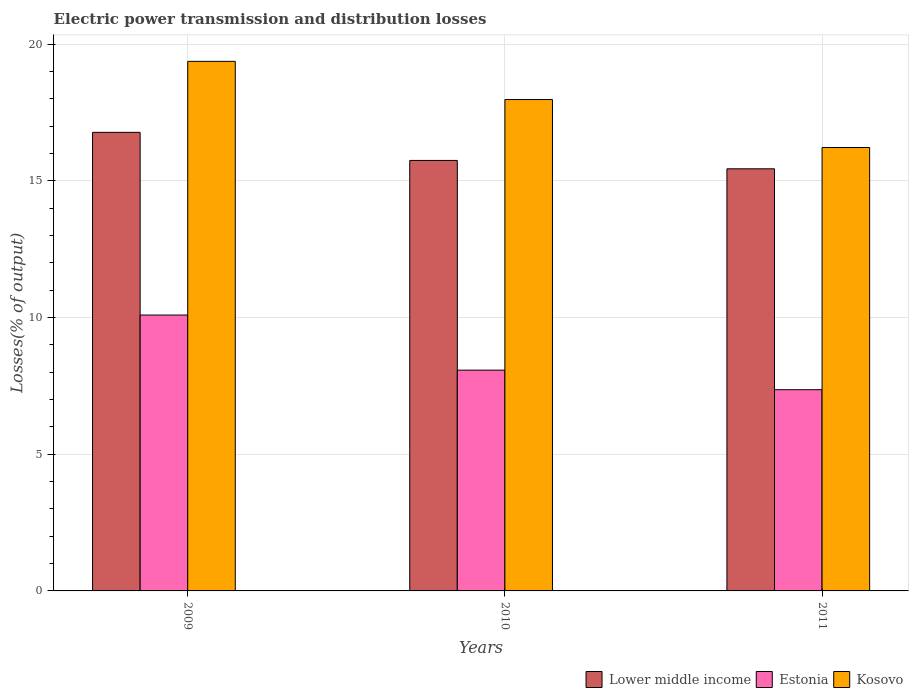How many different coloured bars are there?
Provide a succinct answer. 3. How many groups of bars are there?
Provide a succinct answer. 3. Are the number of bars on each tick of the X-axis equal?
Keep it short and to the point. Yes. What is the label of the 3rd group of bars from the left?
Offer a terse response. 2011. What is the electric power transmission and distribution losses in Lower middle income in 2011?
Offer a very short reply. 15.44. Across all years, what is the maximum electric power transmission and distribution losses in Estonia?
Offer a very short reply. 10.09. Across all years, what is the minimum electric power transmission and distribution losses in Kosovo?
Provide a succinct answer. 16.22. In which year was the electric power transmission and distribution losses in Lower middle income maximum?
Ensure brevity in your answer.  2009. In which year was the electric power transmission and distribution losses in Kosovo minimum?
Ensure brevity in your answer.  2011. What is the total electric power transmission and distribution losses in Estonia in the graph?
Provide a short and direct response. 25.53. What is the difference between the electric power transmission and distribution losses in Estonia in 2009 and that in 2010?
Your answer should be very brief. 2.02. What is the difference between the electric power transmission and distribution losses in Lower middle income in 2011 and the electric power transmission and distribution losses in Estonia in 2009?
Offer a terse response. 5.35. What is the average electric power transmission and distribution losses in Kosovo per year?
Offer a very short reply. 17.86. In the year 2011, what is the difference between the electric power transmission and distribution losses in Lower middle income and electric power transmission and distribution losses in Kosovo?
Ensure brevity in your answer.  -0.78. In how many years, is the electric power transmission and distribution losses in Kosovo greater than 18 %?
Your response must be concise. 1. What is the ratio of the electric power transmission and distribution losses in Kosovo in 2010 to that in 2011?
Give a very brief answer. 1.11. Is the electric power transmission and distribution losses in Lower middle income in 2009 less than that in 2010?
Provide a short and direct response. No. Is the difference between the electric power transmission and distribution losses in Lower middle income in 2009 and 2011 greater than the difference between the electric power transmission and distribution losses in Kosovo in 2009 and 2011?
Offer a very short reply. No. What is the difference between the highest and the second highest electric power transmission and distribution losses in Kosovo?
Your response must be concise. 1.4. What is the difference between the highest and the lowest electric power transmission and distribution losses in Estonia?
Provide a succinct answer. 2.73. In how many years, is the electric power transmission and distribution losses in Lower middle income greater than the average electric power transmission and distribution losses in Lower middle income taken over all years?
Your response must be concise. 1. Is the sum of the electric power transmission and distribution losses in Estonia in 2009 and 2011 greater than the maximum electric power transmission and distribution losses in Kosovo across all years?
Your response must be concise. No. What does the 3rd bar from the left in 2009 represents?
Keep it short and to the point. Kosovo. What does the 1st bar from the right in 2009 represents?
Provide a short and direct response. Kosovo. Is it the case that in every year, the sum of the electric power transmission and distribution losses in Lower middle income and electric power transmission and distribution losses in Estonia is greater than the electric power transmission and distribution losses in Kosovo?
Provide a short and direct response. Yes. Are all the bars in the graph horizontal?
Your response must be concise. No. What is the difference between two consecutive major ticks on the Y-axis?
Keep it short and to the point. 5. Are the values on the major ticks of Y-axis written in scientific E-notation?
Offer a terse response. No. Does the graph contain any zero values?
Offer a very short reply. No. Where does the legend appear in the graph?
Make the answer very short. Bottom right. What is the title of the graph?
Your response must be concise. Electric power transmission and distribution losses. Does "Benin" appear as one of the legend labels in the graph?
Your answer should be compact. No. What is the label or title of the X-axis?
Make the answer very short. Years. What is the label or title of the Y-axis?
Provide a succinct answer. Losses(% of output). What is the Losses(% of output) of Lower middle income in 2009?
Ensure brevity in your answer.  16.78. What is the Losses(% of output) of Estonia in 2009?
Provide a short and direct response. 10.09. What is the Losses(% of output) of Kosovo in 2009?
Provide a succinct answer. 19.37. What is the Losses(% of output) in Lower middle income in 2010?
Offer a very short reply. 15.75. What is the Losses(% of output) of Estonia in 2010?
Ensure brevity in your answer.  8.08. What is the Losses(% of output) in Kosovo in 2010?
Provide a short and direct response. 17.98. What is the Losses(% of output) in Lower middle income in 2011?
Provide a short and direct response. 15.44. What is the Losses(% of output) in Estonia in 2011?
Make the answer very short. 7.36. What is the Losses(% of output) in Kosovo in 2011?
Your response must be concise. 16.22. Across all years, what is the maximum Losses(% of output) in Lower middle income?
Your answer should be compact. 16.78. Across all years, what is the maximum Losses(% of output) of Estonia?
Offer a terse response. 10.09. Across all years, what is the maximum Losses(% of output) in Kosovo?
Give a very brief answer. 19.37. Across all years, what is the minimum Losses(% of output) in Lower middle income?
Keep it short and to the point. 15.44. Across all years, what is the minimum Losses(% of output) of Estonia?
Keep it short and to the point. 7.36. Across all years, what is the minimum Losses(% of output) in Kosovo?
Keep it short and to the point. 16.22. What is the total Losses(% of output) in Lower middle income in the graph?
Provide a short and direct response. 47.97. What is the total Losses(% of output) in Estonia in the graph?
Make the answer very short. 25.53. What is the total Losses(% of output) in Kosovo in the graph?
Ensure brevity in your answer.  53.57. What is the difference between the Losses(% of output) of Lower middle income in 2009 and that in 2010?
Provide a short and direct response. 1.03. What is the difference between the Losses(% of output) in Estonia in 2009 and that in 2010?
Make the answer very short. 2.02. What is the difference between the Losses(% of output) in Kosovo in 2009 and that in 2010?
Ensure brevity in your answer.  1.4. What is the difference between the Losses(% of output) of Lower middle income in 2009 and that in 2011?
Provide a succinct answer. 1.33. What is the difference between the Losses(% of output) of Estonia in 2009 and that in 2011?
Your answer should be compact. 2.73. What is the difference between the Losses(% of output) of Kosovo in 2009 and that in 2011?
Offer a very short reply. 3.15. What is the difference between the Losses(% of output) in Lower middle income in 2010 and that in 2011?
Give a very brief answer. 0.31. What is the difference between the Losses(% of output) of Estonia in 2010 and that in 2011?
Ensure brevity in your answer.  0.72. What is the difference between the Losses(% of output) of Kosovo in 2010 and that in 2011?
Offer a very short reply. 1.75. What is the difference between the Losses(% of output) of Lower middle income in 2009 and the Losses(% of output) of Estonia in 2010?
Provide a short and direct response. 8.7. What is the difference between the Losses(% of output) of Lower middle income in 2009 and the Losses(% of output) of Kosovo in 2010?
Make the answer very short. -1.2. What is the difference between the Losses(% of output) in Estonia in 2009 and the Losses(% of output) in Kosovo in 2010?
Keep it short and to the point. -7.88. What is the difference between the Losses(% of output) in Lower middle income in 2009 and the Losses(% of output) in Estonia in 2011?
Keep it short and to the point. 9.41. What is the difference between the Losses(% of output) in Lower middle income in 2009 and the Losses(% of output) in Kosovo in 2011?
Offer a very short reply. 0.55. What is the difference between the Losses(% of output) in Estonia in 2009 and the Losses(% of output) in Kosovo in 2011?
Ensure brevity in your answer.  -6.13. What is the difference between the Losses(% of output) in Lower middle income in 2010 and the Losses(% of output) in Estonia in 2011?
Provide a short and direct response. 8.39. What is the difference between the Losses(% of output) in Lower middle income in 2010 and the Losses(% of output) in Kosovo in 2011?
Make the answer very short. -0.47. What is the difference between the Losses(% of output) in Estonia in 2010 and the Losses(% of output) in Kosovo in 2011?
Provide a short and direct response. -8.15. What is the average Losses(% of output) in Lower middle income per year?
Give a very brief answer. 15.99. What is the average Losses(% of output) in Estonia per year?
Ensure brevity in your answer.  8.51. What is the average Losses(% of output) in Kosovo per year?
Your answer should be compact. 17.86. In the year 2009, what is the difference between the Losses(% of output) of Lower middle income and Losses(% of output) of Estonia?
Provide a succinct answer. 6.68. In the year 2009, what is the difference between the Losses(% of output) in Lower middle income and Losses(% of output) in Kosovo?
Give a very brief answer. -2.6. In the year 2009, what is the difference between the Losses(% of output) in Estonia and Losses(% of output) in Kosovo?
Ensure brevity in your answer.  -9.28. In the year 2010, what is the difference between the Losses(% of output) in Lower middle income and Losses(% of output) in Estonia?
Offer a terse response. 7.67. In the year 2010, what is the difference between the Losses(% of output) in Lower middle income and Losses(% of output) in Kosovo?
Offer a very short reply. -2.23. In the year 2010, what is the difference between the Losses(% of output) in Estonia and Losses(% of output) in Kosovo?
Your response must be concise. -9.9. In the year 2011, what is the difference between the Losses(% of output) of Lower middle income and Losses(% of output) of Estonia?
Make the answer very short. 8.08. In the year 2011, what is the difference between the Losses(% of output) of Lower middle income and Losses(% of output) of Kosovo?
Provide a succinct answer. -0.78. In the year 2011, what is the difference between the Losses(% of output) of Estonia and Losses(% of output) of Kosovo?
Your answer should be very brief. -8.86. What is the ratio of the Losses(% of output) in Lower middle income in 2009 to that in 2010?
Offer a terse response. 1.07. What is the ratio of the Losses(% of output) in Estonia in 2009 to that in 2010?
Provide a short and direct response. 1.25. What is the ratio of the Losses(% of output) in Kosovo in 2009 to that in 2010?
Keep it short and to the point. 1.08. What is the ratio of the Losses(% of output) of Lower middle income in 2009 to that in 2011?
Give a very brief answer. 1.09. What is the ratio of the Losses(% of output) of Estonia in 2009 to that in 2011?
Give a very brief answer. 1.37. What is the ratio of the Losses(% of output) of Kosovo in 2009 to that in 2011?
Provide a short and direct response. 1.19. What is the ratio of the Losses(% of output) in Lower middle income in 2010 to that in 2011?
Your response must be concise. 1.02. What is the ratio of the Losses(% of output) of Estonia in 2010 to that in 2011?
Offer a terse response. 1.1. What is the ratio of the Losses(% of output) of Kosovo in 2010 to that in 2011?
Offer a terse response. 1.11. What is the difference between the highest and the second highest Losses(% of output) in Lower middle income?
Offer a terse response. 1.03. What is the difference between the highest and the second highest Losses(% of output) in Estonia?
Your response must be concise. 2.02. What is the difference between the highest and the second highest Losses(% of output) of Kosovo?
Offer a very short reply. 1.4. What is the difference between the highest and the lowest Losses(% of output) of Lower middle income?
Keep it short and to the point. 1.33. What is the difference between the highest and the lowest Losses(% of output) in Estonia?
Provide a short and direct response. 2.73. What is the difference between the highest and the lowest Losses(% of output) of Kosovo?
Provide a succinct answer. 3.15. 